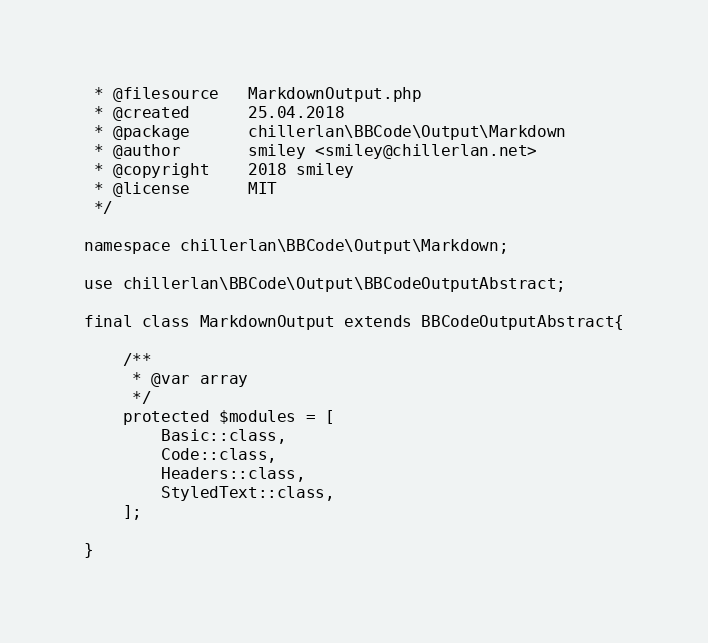Convert code to text. <code><loc_0><loc_0><loc_500><loc_500><_PHP_> * @filesource   MarkdownOutput.php
 * @created      25.04.2018
 * @package      chillerlan\BBCode\Output\Markdown
 * @author       smiley <smiley@chillerlan.net>
 * @copyright    2018 smiley
 * @license      MIT
 */

namespace chillerlan\BBCode\Output\Markdown;

use chillerlan\BBCode\Output\BBCodeOutputAbstract;

final class MarkdownOutput extends BBCodeOutputAbstract{

	/**
	 * @var array
	 */
	protected $modules = [
		Basic::class,
		Code::class,
		Headers::class,
		StyledText::class,
	];

}
</code> 